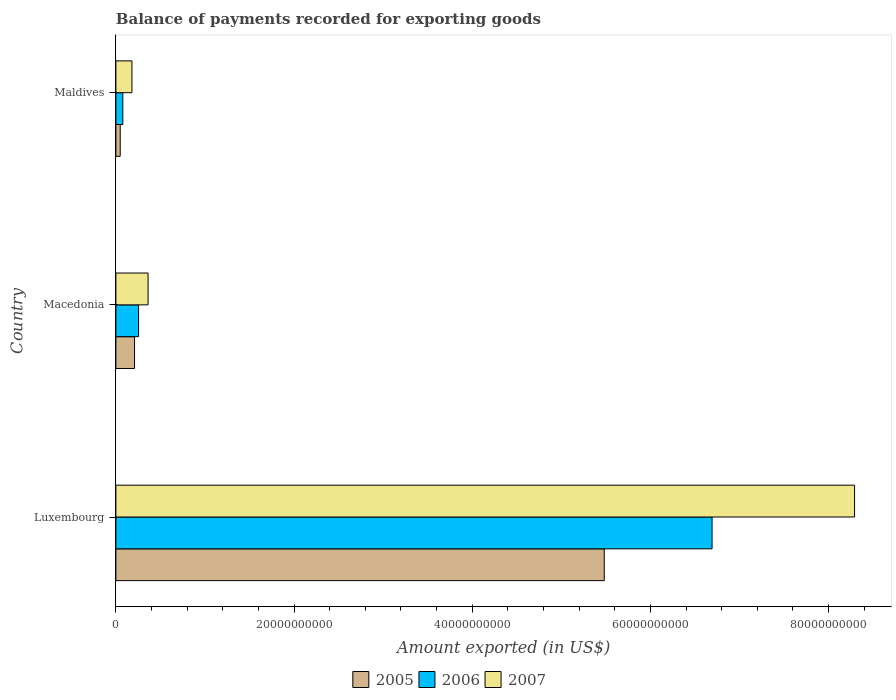How many different coloured bars are there?
Keep it short and to the point. 3. How many groups of bars are there?
Keep it short and to the point. 3. Are the number of bars on each tick of the Y-axis equal?
Provide a succinct answer. Yes. How many bars are there on the 2nd tick from the bottom?
Your response must be concise. 3. What is the label of the 2nd group of bars from the top?
Ensure brevity in your answer.  Macedonia. What is the amount exported in 2005 in Macedonia?
Provide a succinct answer. 2.09e+09. Across all countries, what is the maximum amount exported in 2007?
Offer a terse response. 8.29e+1. Across all countries, what is the minimum amount exported in 2007?
Offer a very short reply. 1.80e+09. In which country was the amount exported in 2005 maximum?
Your response must be concise. Luxembourg. In which country was the amount exported in 2005 minimum?
Your answer should be very brief. Maldives. What is the total amount exported in 2006 in the graph?
Provide a short and direct response. 7.02e+1. What is the difference between the amount exported in 2006 in Luxembourg and that in Macedonia?
Make the answer very short. 6.44e+1. What is the difference between the amount exported in 2005 in Luxembourg and the amount exported in 2007 in Maldives?
Offer a very short reply. 5.30e+1. What is the average amount exported in 2006 per country?
Your response must be concise. 2.34e+1. What is the difference between the amount exported in 2007 and amount exported in 2006 in Macedonia?
Offer a terse response. 1.07e+09. In how many countries, is the amount exported in 2006 greater than 16000000000 US$?
Provide a short and direct response. 1. What is the ratio of the amount exported in 2005 in Macedonia to that in Maldives?
Ensure brevity in your answer.  4.32. Is the amount exported in 2007 in Macedonia less than that in Maldives?
Offer a very short reply. No. Is the difference between the amount exported in 2007 in Luxembourg and Maldives greater than the difference between the amount exported in 2006 in Luxembourg and Maldives?
Give a very brief answer. Yes. What is the difference between the highest and the second highest amount exported in 2006?
Ensure brevity in your answer.  6.44e+1. What is the difference between the highest and the lowest amount exported in 2006?
Give a very brief answer. 6.61e+1. What does the 3rd bar from the bottom in Macedonia represents?
Offer a terse response. 2007. Is it the case that in every country, the sum of the amount exported in 2007 and amount exported in 2006 is greater than the amount exported in 2005?
Provide a short and direct response. Yes. How many bars are there?
Make the answer very short. 9. What is the difference between two consecutive major ticks on the X-axis?
Ensure brevity in your answer.  2.00e+1. Are the values on the major ticks of X-axis written in scientific E-notation?
Your response must be concise. No. Does the graph contain any zero values?
Keep it short and to the point. No. Does the graph contain grids?
Make the answer very short. No. Where does the legend appear in the graph?
Offer a terse response. Bottom center. How are the legend labels stacked?
Offer a very short reply. Horizontal. What is the title of the graph?
Your answer should be very brief. Balance of payments recorded for exporting goods. What is the label or title of the X-axis?
Offer a terse response. Amount exported (in US$). What is the label or title of the Y-axis?
Provide a succinct answer. Country. What is the Amount exported (in US$) in 2005 in Luxembourg?
Make the answer very short. 5.48e+1. What is the Amount exported (in US$) in 2006 in Luxembourg?
Provide a succinct answer. 6.69e+1. What is the Amount exported (in US$) in 2007 in Luxembourg?
Offer a terse response. 8.29e+1. What is the Amount exported (in US$) of 2005 in Macedonia?
Provide a short and direct response. 2.09e+09. What is the Amount exported (in US$) in 2006 in Macedonia?
Keep it short and to the point. 2.55e+09. What is the Amount exported (in US$) in 2007 in Macedonia?
Provide a short and direct response. 3.61e+09. What is the Amount exported (in US$) of 2005 in Maldives?
Your response must be concise. 4.85e+08. What is the Amount exported (in US$) in 2006 in Maldives?
Provide a short and direct response. 7.77e+08. What is the Amount exported (in US$) of 2007 in Maldives?
Your answer should be compact. 1.80e+09. Across all countries, what is the maximum Amount exported (in US$) of 2005?
Ensure brevity in your answer.  5.48e+1. Across all countries, what is the maximum Amount exported (in US$) of 2006?
Your response must be concise. 6.69e+1. Across all countries, what is the maximum Amount exported (in US$) of 2007?
Your answer should be compact. 8.29e+1. Across all countries, what is the minimum Amount exported (in US$) in 2005?
Your answer should be compact. 4.85e+08. Across all countries, what is the minimum Amount exported (in US$) of 2006?
Your answer should be compact. 7.77e+08. Across all countries, what is the minimum Amount exported (in US$) in 2007?
Offer a very short reply. 1.80e+09. What is the total Amount exported (in US$) of 2005 in the graph?
Your answer should be very brief. 5.74e+1. What is the total Amount exported (in US$) of 2006 in the graph?
Keep it short and to the point. 7.02e+1. What is the total Amount exported (in US$) in 2007 in the graph?
Your response must be concise. 8.83e+1. What is the difference between the Amount exported (in US$) of 2005 in Luxembourg and that in Macedonia?
Your response must be concise. 5.27e+1. What is the difference between the Amount exported (in US$) in 2006 in Luxembourg and that in Macedonia?
Offer a terse response. 6.44e+1. What is the difference between the Amount exported (in US$) of 2007 in Luxembourg and that in Macedonia?
Give a very brief answer. 7.93e+1. What is the difference between the Amount exported (in US$) in 2005 in Luxembourg and that in Maldives?
Provide a succinct answer. 5.43e+1. What is the difference between the Amount exported (in US$) in 2006 in Luxembourg and that in Maldives?
Keep it short and to the point. 6.61e+1. What is the difference between the Amount exported (in US$) of 2007 in Luxembourg and that in Maldives?
Your answer should be very brief. 8.11e+1. What is the difference between the Amount exported (in US$) of 2005 in Macedonia and that in Maldives?
Make the answer very short. 1.61e+09. What is the difference between the Amount exported (in US$) of 2006 in Macedonia and that in Maldives?
Make the answer very short. 1.77e+09. What is the difference between the Amount exported (in US$) of 2007 in Macedonia and that in Maldives?
Ensure brevity in your answer.  1.81e+09. What is the difference between the Amount exported (in US$) in 2005 in Luxembourg and the Amount exported (in US$) in 2006 in Macedonia?
Ensure brevity in your answer.  5.23e+1. What is the difference between the Amount exported (in US$) in 2005 in Luxembourg and the Amount exported (in US$) in 2007 in Macedonia?
Provide a short and direct response. 5.12e+1. What is the difference between the Amount exported (in US$) of 2006 in Luxembourg and the Amount exported (in US$) of 2007 in Macedonia?
Give a very brief answer. 6.33e+1. What is the difference between the Amount exported (in US$) in 2005 in Luxembourg and the Amount exported (in US$) in 2006 in Maldives?
Your answer should be very brief. 5.40e+1. What is the difference between the Amount exported (in US$) of 2005 in Luxembourg and the Amount exported (in US$) of 2007 in Maldives?
Keep it short and to the point. 5.30e+1. What is the difference between the Amount exported (in US$) of 2006 in Luxembourg and the Amount exported (in US$) of 2007 in Maldives?
Give a very brief answer. 6.51e+1. What is the difference between the Amount exported (in US$) of 2005 in Macedonia and the Amount exported (in US$) of 2006 in Maldives?
Your answer should be very brief. 1.32e+09. What is the difference between the Amount exported (in US$) of 2005 in Macedonia and the Amount exported (in US$) of 2007 in Maldives?
Give a very brief answer. 2.90e+08. What is the difference between the Amount exported (in US$) of 2006 in Macedonia and the Amount exported (in US$) of 2007 in Maldives?
Your answer should be very brief. 7.42e+08. What is the average Amount exported (in US$) of 2005 per country?
Offer a very short reply. 1.91e+1. What is the average Amount exported (in US$) of 2006 per country?
Provide a short and direct response. 2.34e+1. What is the average Amount exported (in US$) in 2007 per country?
Make the answer very short. 2.94e+1. What is the difference between the Amount exported (in US$) in 2005 and Amount exported (in US$) in 2006 in Luxembourg?
Keep it short and to the point. -1.21e+1. What is the difference between the Amount exported (in US$) of 2005 and Amount exported (in US$) of 2007 in Luxembourg?
Provide a short and direct response. -2.81e+1. What is the difference between the Amount exported (in US$) in 2006 and Amount exported (in US$) in 2007 in Luxembourg?
Your answer should be very brief. -1.60e+1. What is the difference between the Amount exported (in US$) in 2005 and Amount exported (in US$) in 2006 in Macedonia?
Your answer should be very brief. -4.52e+08. What is the difference between the Amount exported (in US$) in 2005 and Amount exported (in US$) in 2007 in Macedonia?
Your response must be concise. -1.52e+09. What is the difference between the Amount exported (in US$) of 2006 and Amount exported (in US$) of 2007 in Macedonia?
Your answer should be very brief. -1.07e+09. What is the difference between the Amount exported (in US$) in 2005 and Amount exported (in US$) in 2006 in Maldives?
Make the answer very short. -2.93e+08. What is the difference between the Amount exported (in US$) in 2005 and Amount exported (in US$) in 2007 in Maldives?
Provide a succinct answer. -1.32e+09. What is the difference between the Amount exported (in US$) in 2006 and Amount exported (in US$) in 2007 in Maldives?
Provide a short and direct response. -1.03e+09. What is the ratio of the Amount exported (in US$) in 2005 in Luxembourg to that in Macedonia?
Give a very brief answer. 26.19. What is the ratio of the Amount exported (in US$) in 2006 in Luxembourg to that in Macedonia?
Your answer should be very brief. 26.29. What is the ratio of the Amount exported (in US$) in 2007 in Luxembourg to that in Macedonia?
Ensure brevity in your answer.  22.96. What is the ratio of the Amount exported (in US$) in 2005 in Luxembourg to that in Maldives?
Offer a terse response. 113.14. What is the ratio of the Amount exported (in US$) of 2006 in Luxembourg to that in Maldives?
Give a very brief answer. 86.11. What is the ratio of the Amount exported (in US$) of 2007 in Luxembourg to that in Maldives?
Your response must be concise. 45.97. What is the ratio of the Amount exported (in US$) of 2005 in Macedonia to that in Maldives?
Make the answer very short. 4.32. What is the ratio of the Amount exported (in US$) of 2006 in Macedonia to that in Maldives?
Keep it short and to the point. 3.28. What is the ratio of the Amount exported (in US$) in 2007 in Macedonia to that in Maldives?
Give a very brief answer. 2. What is the difference between the highest and the second highest Amount exported (in US$) of 2005?
Your answer should be compact. 5.27e+1. What is the difference between the highest and the second highest Amount exported (in US$) in 2006?
Ensure brevity in your answer.  6.44e+1. What is the difference between the highest and the second highest Amount exported (in US$) in 2007?
Give a very brief answer. 7.93e+1. What is the difference between the highest and the lowest Amount exported (in US$) in 2005?
Your answer should be compact. 5.43e+1. What is the difference between the highest and the lowest Amount exported (in US$) of 2006?
Keep it short and to the point. 6.61e+1. What is the difference between the highest and the lowest Amount exported (in US$) of 2007?
Make the answer very short. 8.11e+1. 